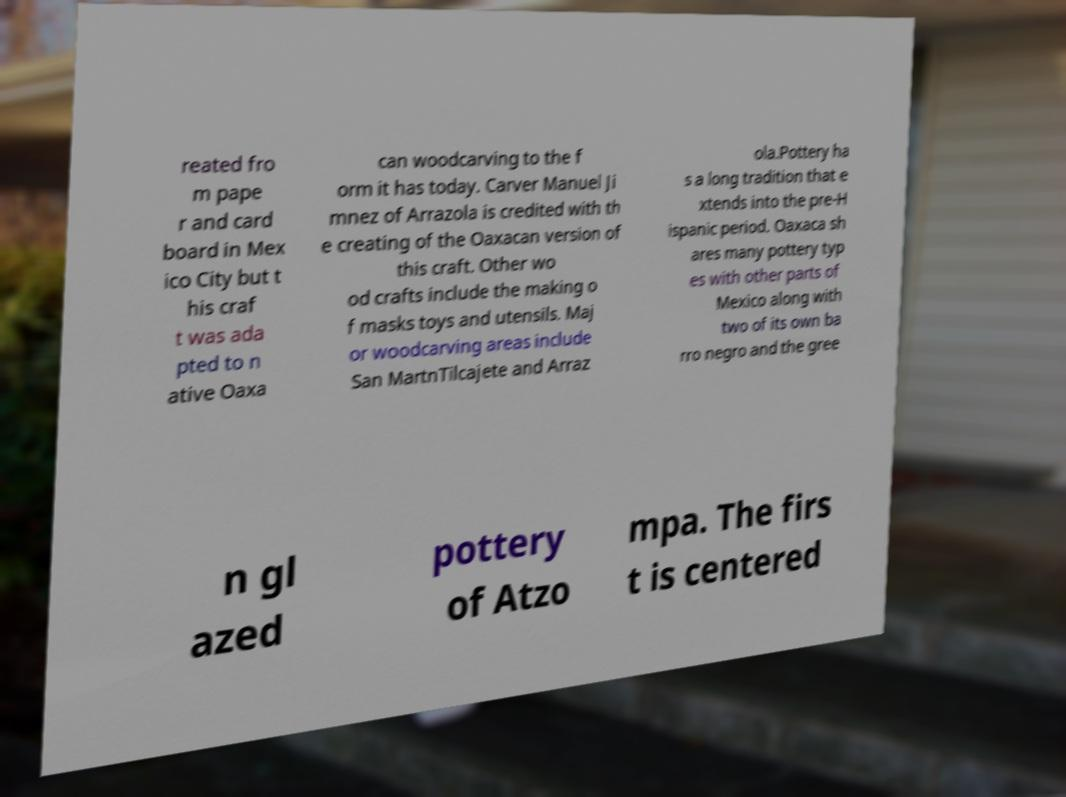Please identify and transcribe the text found in this image. reated fro m pape r and card board in Mex ico City but t his craf t was ada pted to n ative Oaxa can woodcarving to the f orm it has today. Carver Manuel Ji mnez of Arrazola is credited with th e creating of the Oaxacan version of this craft. Other wo od crafts include the making o f masks toys and utensils. Maj or woodcarving areas include San MartnTilcajete and Arraz ola.Pottery ha s a long tradition that e xtends into the pre-H ispanic period. Oaxaca sh ares many pottery typ es with other parts of Mexico along with two of its own ba rro negro and the gree n gl azed pottery of Atzo mpa. The firs t is centered 